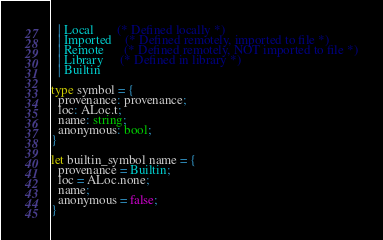Convert code to text. <code><loc_0><loc_0><loc_500><loc_500><_OCaml_>  | Local       (* Defined locally *)
  | Imported    (* Defined remotely, imported to file *)
  | Remote      (* Defined remotely, NOT imported to file *)
  | Library     (* Defined in library *)
  | Builtin

type symbol = {
  provenance: provenance;
  loc: ALoc.t;
  name: string;
  anonymous: bool;
}

let builtin_symbol name = {
  provenance = Builtin;
  loc = ALoc.none;
  name;
  anonymous = false;
}
</code> 